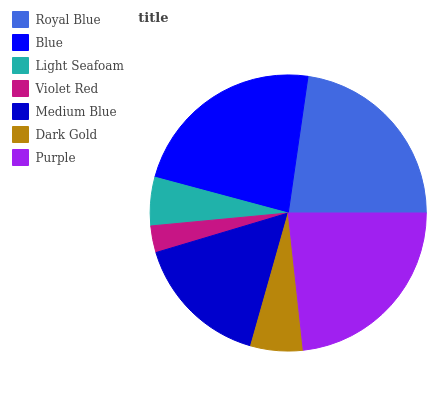Is Violet Red the minimum?
Answer yes or no. Yes. Is Purple the maximum?
Answer yes or no. Yes. Is Blue the minimum?
Answer yes or no. No. Is Blue the maximum?
Answer yes or no. No. Is Blue greater than Royal Blue?
Answer yes or no. Yes. Is Royal Blue less than Blue?
Answer yes or no. Yes. Is Royal Blue greater than Blue?
Answer yes or no. No. Is Blue less than Royal Blue?
Answer yes or no. No. Is Medium Blue the high median?
Answer yes or no. Yes. Is Medium Blue the low median?
Answer yes or no. Yes. Is Violet Red the high median?
Answer yes or no. No. Is Dark Gold the low median?
Answer yes or no. No. 